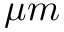<formula> <loc_0><loc_0><loc_500><loc_500>\mu m</formula> 